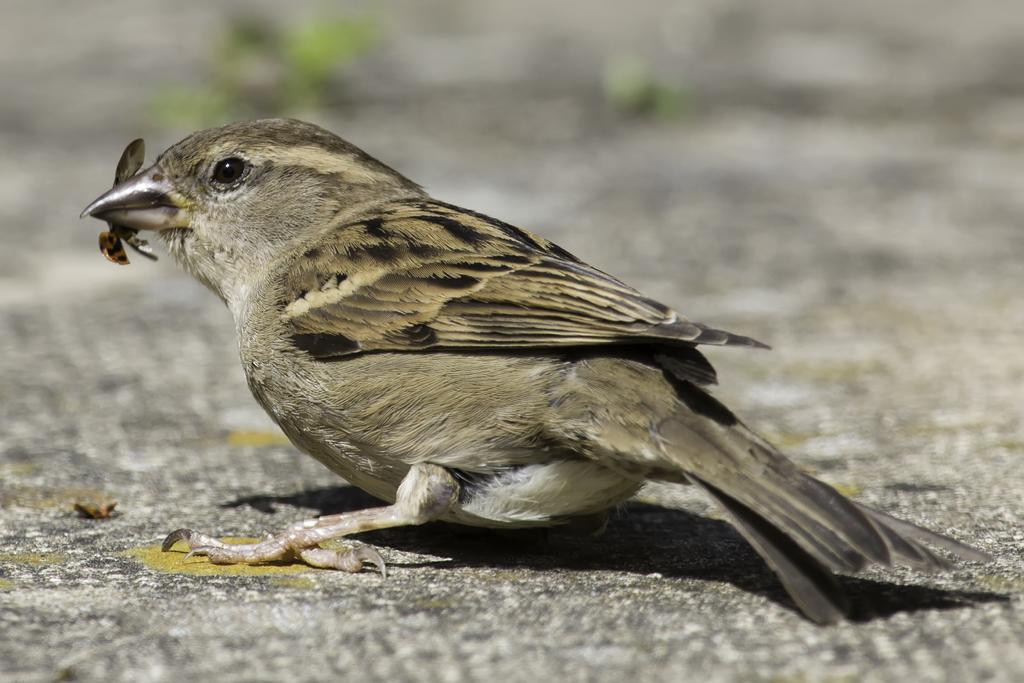What type of bird is in the image? There is a sparrow in the image. Where is the sparrow located? The sparrow is sitting on the road. What is the sparrow holding in its mouth? The sparrow has an insect in its mouth. Can you describe the background of the image? The background of the image is blurred. What type of polish is the sparrow applying to its feathers in the image? There is no polish or any indication of the sparrow applying anything to its feathers in the image. 